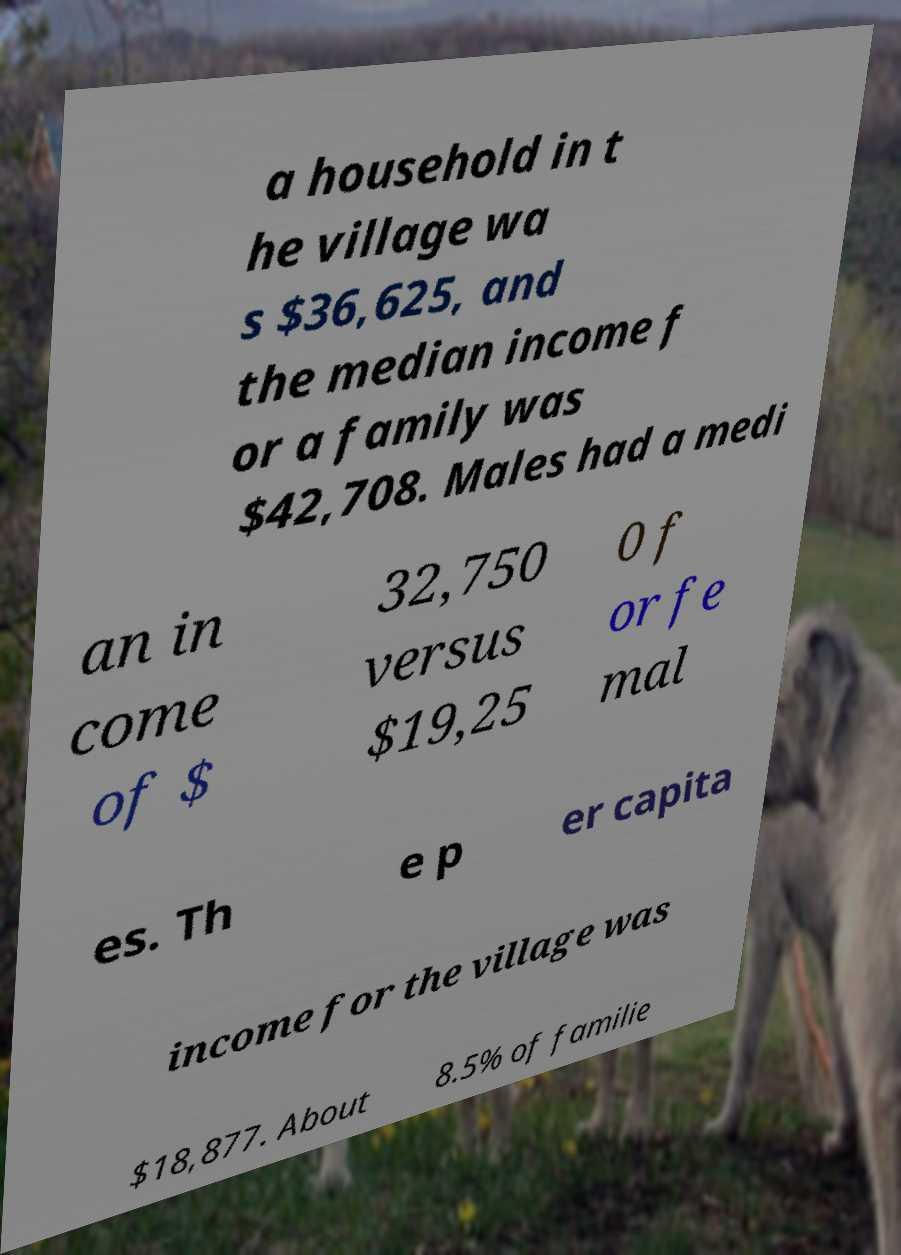Can you read and provide the text displayed in the image?This photo seems to have some interesting text. Can you extract and type it out for me? a household in t he village wa s $36,625, and the median income f or a family was $42,708. Males had a medi an in come of $ 32,750 versus $19,25 0 f or fe mal es. Th e p er capita income for the village was $18,877. About 8.5% of familie 